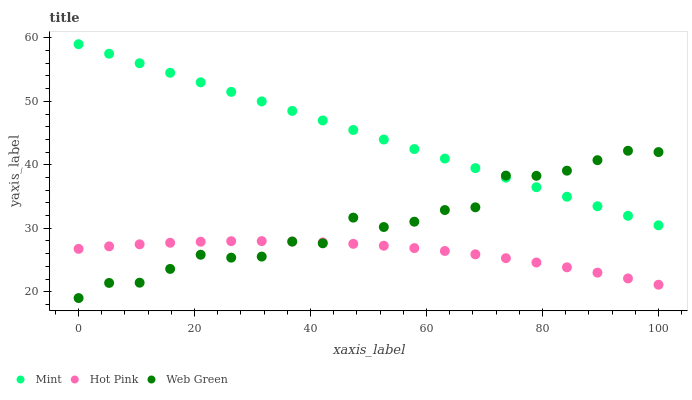Does Hot Pink have the minimum area under the curve?
Answer yes or no. Yes. Does Mint have the maximum area under the curve?
Answer yes or no. Yes. Does Web Green have the minimum area under the curve?
Answer yes or no. No. Does Web Green have the maximum area under the curve?
Answer yes or no. No. Is Mint the smoothest?
Answer yes or no. Yes. Is Web Green the roughest?
Answer yes or no. Yes. Is Web Green the smoothest?
Answer yes or no. No. Is Mint the roughest?
Answer yes or no. No. Does Web Green have the lowest value?
Answer yes or no. Yes. Does Mint have the lowest value?
Answer yes or no. No. Does Mint have the highest value?
Answer yes or no. Yes. Does Web Green have the highest value?
Answer yes or no. No. Is Hot Pink less than Mint?
Answer yes or no. Yes. Is Mint greater than Hot Pink?
Answer yes or no. Yes. Does Mint intersect Web Green?
Answer yes or no. Yes. Is Mint less than Web Green?
Answer yes or no. No. Is Mint greater than Web Green?
Answer yes or no. No. Does Hot Pink intersect Mint?
Answer yes or no. No. 